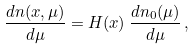Convert formula to latex. <formula><loc_0><loc_0><loc_500><loc_500>\frac { d n ( x , \mu ) } { d \mu } = H ( x ) \, \frac { d n _ { 0 } ( \mu ) } { d \mu } \, ,</formula> 